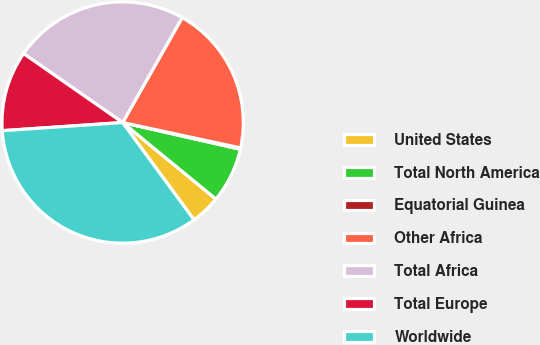Convert chart to OTSL. <chart><loc_0><loc_0><loc_500><loc_500><pie_chart><fcel>United States<fcel>Total North America<fcel>Equatorial Guinea<fcel>Other Africa<fcel>Total Africa<fcel>Total Europe<fcel>Worldwide<nl><fcel>3.99%<fcel>7.38%<fcel>0.18%<fcel>20.16%<fcel>23.54%<fcel>10.76%<fcel>34.0%<nl></chart> 